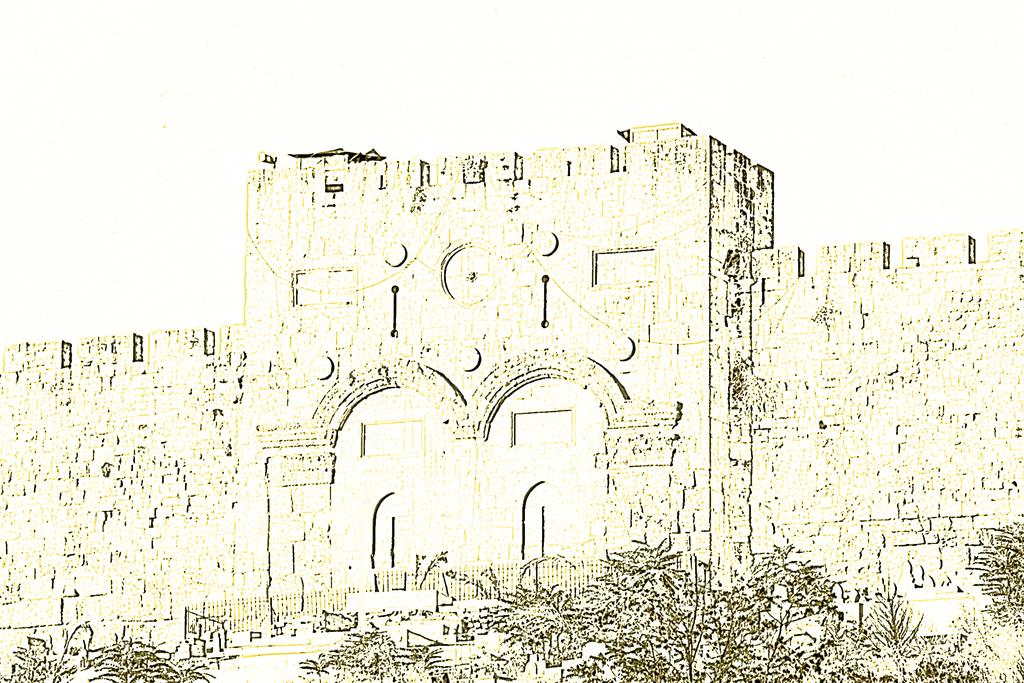What type of image is being described? The image is an edited picture. What is the main subject of the image? There is a fort in the image. What else can be seen in the image besides the fort? There are plants in the image. What color is the background of the image? The background of the image is white. What time of day is it in the image? The time of day is not mentioned or depicted in the image, so it cannot be determined. 